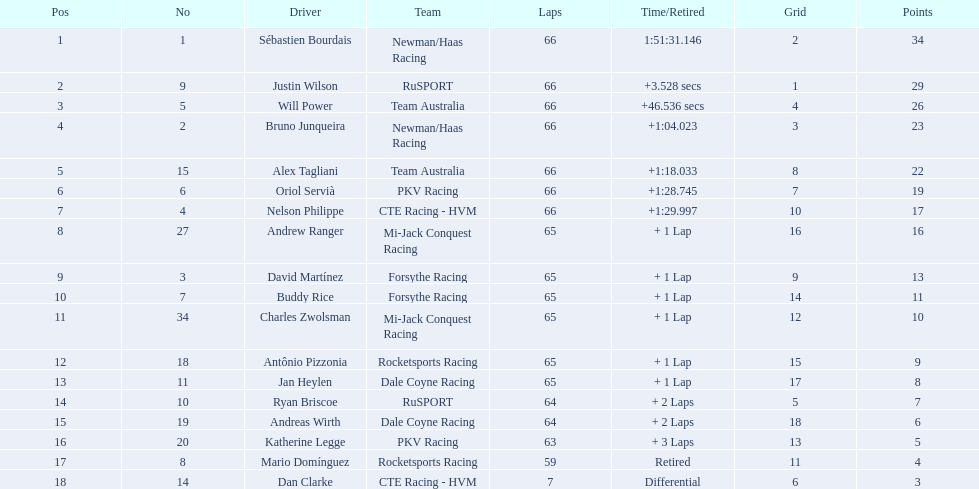Which drivers earned not less than 10 points? Sébastien Bourdais, Justin Wilson, Will Power, Bruno Junqueira, Alex Tagliani, Oriol Servià, Nelson Philippe, Andrew Ranger, David Martínez, Buddy Rice, Charles Zwolsman. Of those drivers, which ones achieved at least 20 points? Sébastien Bourdais, Justin Wilson, Will Power, Bruno Junqueira, Alex Tagliani. Of those 5, which driver had the maximum points? Sébastien Bourdais. 